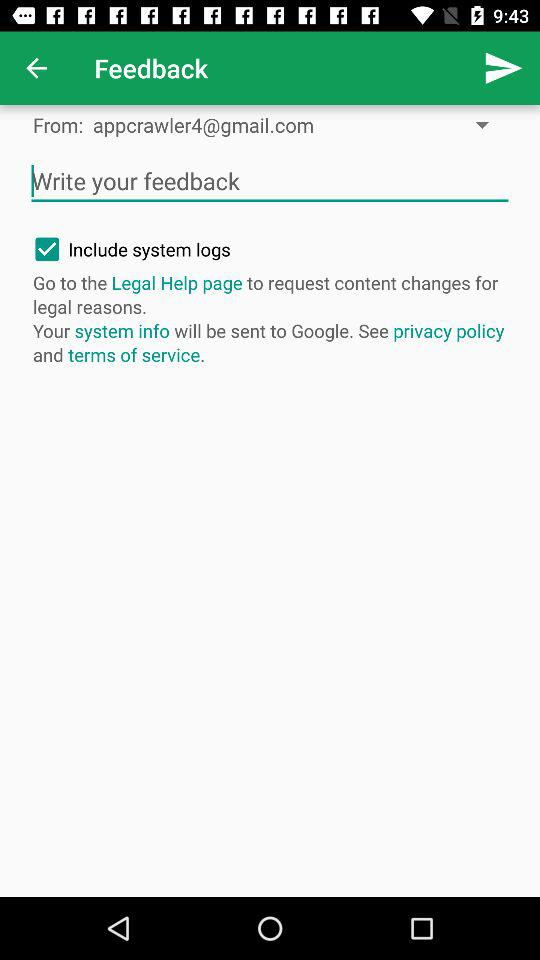What is the email address? The email address is appcrawler4@gmail.com. 